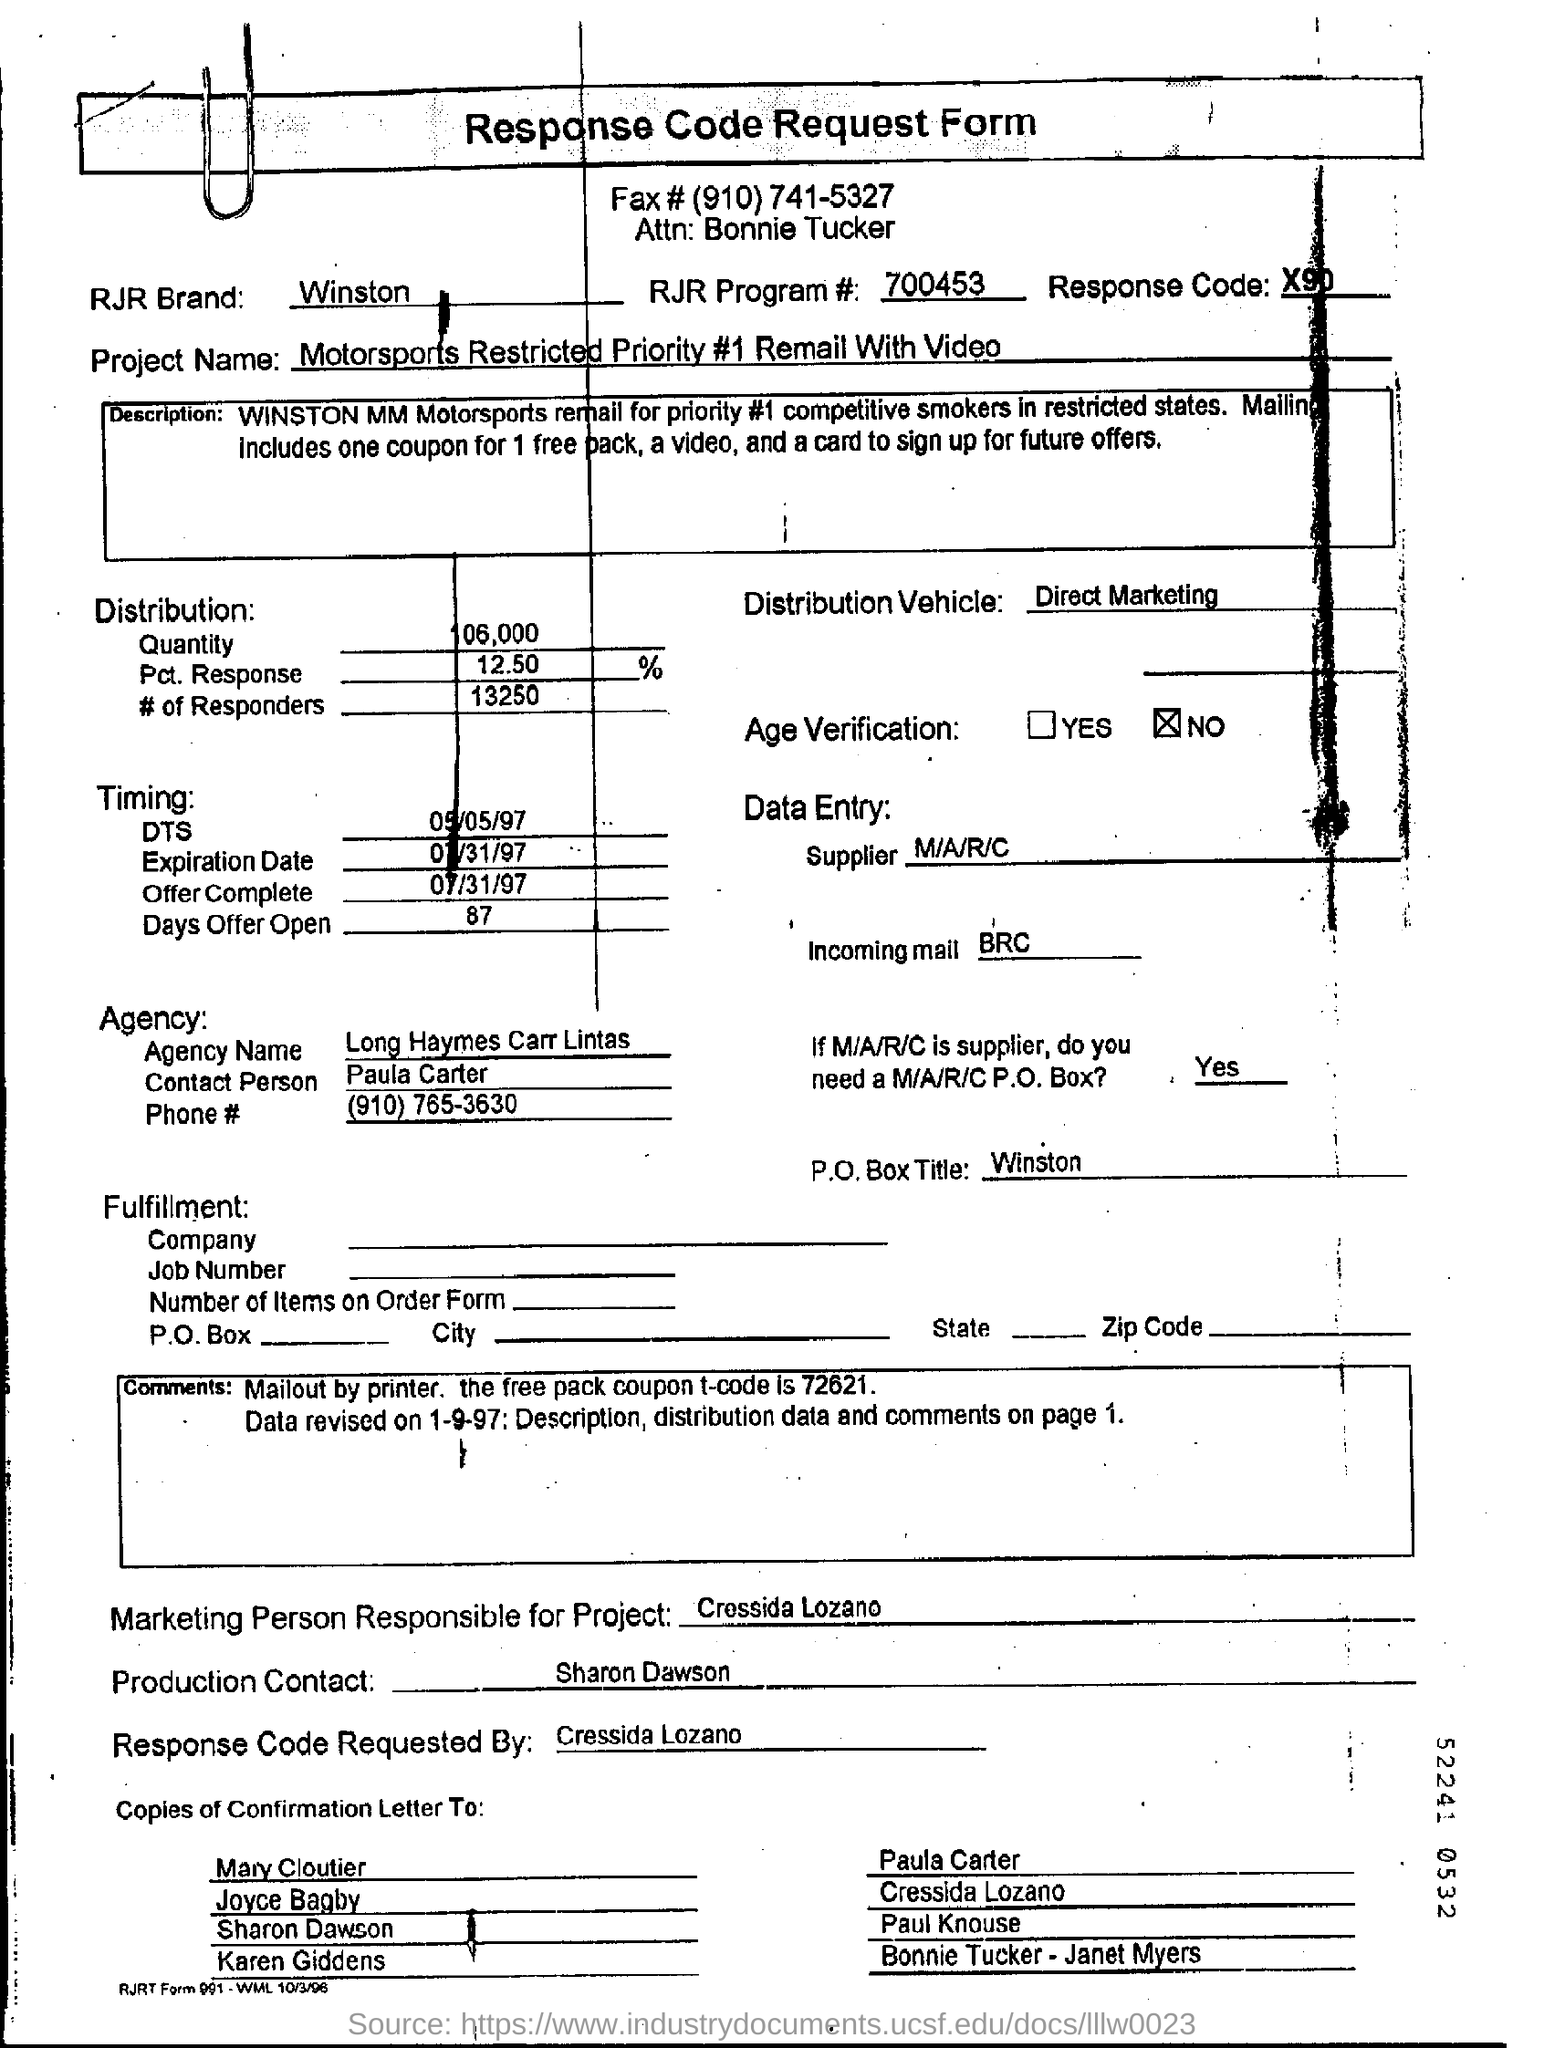Identify some key points in this picture. The RJR Brand Field contains the written information 'Winston.' The Distribution Vehicle Field mentions the term 'Direct Marketing.' The agency name is Long Haymes Carr Lintas. The Offer Complete Date, as indicated in the document, is 07/31/97. The RJR Program Number is 700453, with a decimal point separating the thousands and hundreds digits, respectively. 